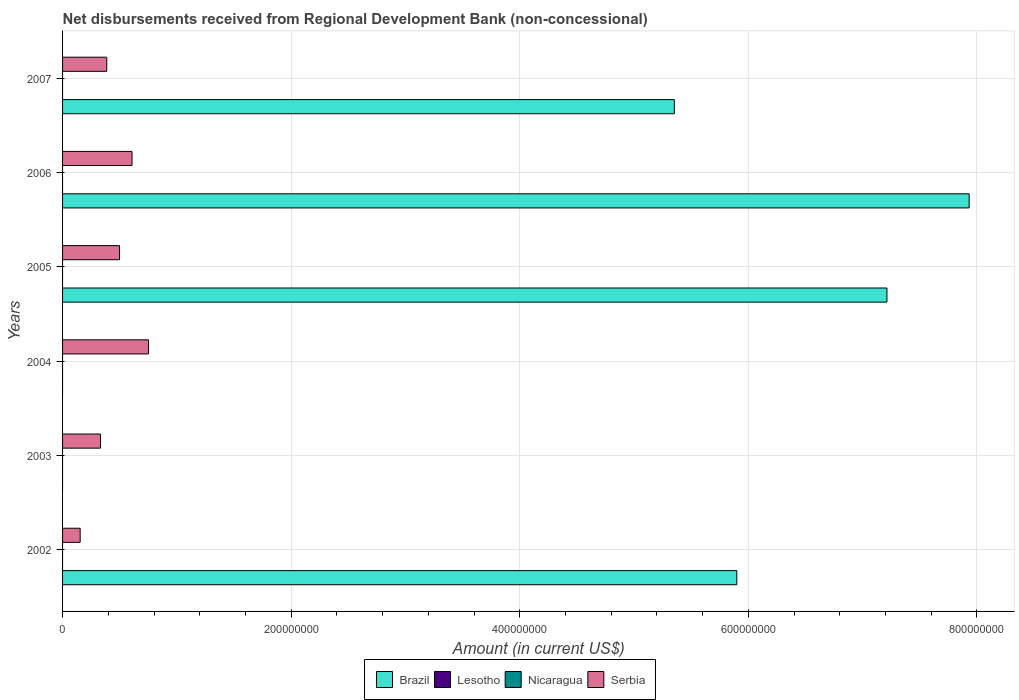Are the number of bars on each tick of the Y-axis equal?
Your answer should be very brief. No. How many bars are there on the 5th tick from the top?
Provide a short and direct response. 1. In how many cases, is the number of bars for a given year not equal to the number of legend labels?
Offer a very short reply. 6. What is the amount of disbursements received from Regional Development Bank in Nicaragua in 2004?
Make the answer very short. 0. Across all years, what is the maximum amount of disbursements received from Regional Development Bank in Serbia?
Provide a short and direct response. 7.52e+07. Across all years, what is the minimum amount of disbursements received from Regional Development Bank in Lesotho?
Your answer should be very brief. 0. In which year was the amount of disbursements received from Regional Development Bank in Serbia maximum?
Your response must be concise. 2004. What is the total amount of disbursements received from Regional Development Bank in Nicaragua in the graph?
Keep it short and to the point. 0. What is the difference between the amount of disbursements received from Regional Development Bank in Serbia in 2002 and that in 2005?
Provide a short and direct response. -3.44e+07. What is the ratio of the amount of disbursements received from Regional Development Bank in Serbia in 2005 to that in 2007?
Make the answer very short. 1.29. Is the amount of disbursements received from Regional Development Bank in Serbia in 2004 less than that in 2007?
Make the answer very short. No. What is the difference between the highest and the second highest amount of disbursements received from Regional Development Bank in Brazil?
Ensure brevity in your answer.  7.19e+07. What is the difference between the highest and the lowest amount of disbursements received from Regional Development Bank in Serbia?
Provide a succinct answer. 5.98e+07. Is the sum of the amount of disbursements received from Regional Development Bank in Brazil in 2002 and 2006 greater than the maximum amount of disbursements received from Regional Development Bank in Nicaragua across all years?
Ensure brevity in your answer.  Yes. Is it the case that in every year, the sum of the amount of disbursements received from Regional Development Bank in Lesotho and amount of disbursements received from Regional Development Bank in Serbia is greater than the sum of amount of disbursements received from Regional Development Bank in Nicaragua and amount of disbursements received from Regional Development Bank in Brazil?
Give a very brief answer. Yes. Is it the case that in every year, the sum of the amount of disbursements received from Regional Development Bank in Serbia and amount of disbursements received from Regional Development Bank in Brazil is greater than the amount of disbursements received from Regional Development Bank in Nicaragua?
Keep it short and to the point. Yes. Are the values on the major ticks of X-axis written in scientific E-notation?
Your response must be concise. No. How many legend labels are there?
Give a very brief answer. 4. What is the title of the graph?
Make the answer very short. Net disbursements received from Regional Development Bank (non-concessional). What is the label or title of the X-axis?
Your answer should be compact. Amount (in current US$). What is the label or title of the Y-axis?
Provide a succinct answer. Years. What is the Amount (in current US$) in Brazil in 2002?
Give a very brief answer. 5.90e+08. What is the Amount (in current US$) in Nicaragua in 2002?
Offer a very short reply. 0. What is the Amount (in current US$) in Serbia in 2002?
Make the answer very short. 1.54e+07. What is the Amount (in current US$) of Brazil in 2003?
Your response must be concise. 0. What is the Amount (in current US$) in Serbia in 2003?
Your answer should be very brief. 3.32e+07. What is the Amount (in current US$) in Brazil in 2004?
Offer a terse response. 0. What is the Amount (in current US$) of Lesotho in 2004?
Offer a very short reply. 0. What is the Amount (in current US$) in Nicaragua in 2004?
Your response must be concise. 0. What is the Amount (in current US$) in Serbia in 2004?
Offer a very short reply. 7.52e+07. What is the Amount (in current US$) in Brazil in 2005?
Your answer should be compact. 7.21e+08. What is the Amount (in current US$) in Nicaragua in 2005?
Keep it short and to the point. 0. What is the Amount (in current US$) of Serbia in 2005?
Your response must be concise. 4.98e+07. What is the Amount (in current US$) of Brazil in 2006?
Provide a succinct answer. 7.93e+08. What is the Amount (in current US$) in Serbia in 2006?
Your response must be concise. 6.08e+07. What is the Amount (in current US$) of Brazil in 2007?
Keep it short and to the point. 5.35e+08. What is the Amount (in current US$) in Lesotho in 2007?
Your response must be concise. 0. What is the Amount (in current US$) of Serbia in 2007?
Keep it short and to the point. 3.87e+07. Across all years, what is the maximum Amount (in current US$) in Brazil?
Your answer should be very brief. 7.93e+08. Across all years, what is the maximum Amount (in current US$) in Serbia?
Offer a very short reply. 7.52e+07. Across all years, what is the minimum Amount (in current US$) in Brazil?
Give a very brief answer. 0. Across all years, what is the minimum Amount (in current US$) of Serbia?
Offer a very short reply. 1.54e+07. What is the total Amount (in current US$) in Brazil in the graph?
Your response must be concise. 2.64e+09. What is the total Amount (in current US$) of Lesotho in the graph?
Your answer should be compact. 0. What is the total Amount (in current US$) in Serbia in the graph?
Give a very brief answer. 2.73e+08. What is the difference between the Amount (in current US$) of Serbia in 2002 and that in 2003?
Offer a very short reply. -1.78e+07. What is the difference between the Amount (in current US$) of Serbia in 2002 and that in 2004?
Keep it short and to the point. -5.98e+07. What is the difference between the Amount (in current US$) of Brazil in 2002 and that in 2005?
Offer a terse response. -1.31e+08. What is the difference between the Amount (in current US$) in Serbia in 2002 and that in 2005?
Your answer should be compact. -3.44e+07. What is the difference between the Amount (in current US$) of Brazil in 2002 and that in 2006?
Offer a terse response. -2.03e+08. What is the difference between the Amount (in current US$) of Serbia in 2002 and that in 2006?
Offer a terse response. -4.54e+07. What is the difference between the Amount (in current US$) in Brazil in 2002 and that in 2007?
Make the answer very short. 5.46e+07. What is the difference between the Amount (in current US$) of Serbia in 2002 and that in 2007?
Your answer should be very brief. -2.33e+07. What is the difference between the Amount (in current US$) in Serbia in 2003 and that in 2004?
Make the answer very short. -4.20e+07. What is the difference between the Amount (in current US$) of Serbia in 2003 and that in 2005?
Your answer should be very brief. -1.67e+07. What is the difference between the Amount (in current US$) in Serbia in 2003 and that in 2006?
Your response must be concise. -2.76e+07. What is the difference between the Amount (in current US$) in Serbia in 2003 and that in 2007?
Provide a short and direct response. -5.47e+06. What is the difference between the Amount (in current US$) in Serbia in 2004 and that in 2005?
Keep it short and to the point. 2.54e+07. What is the difference between the Amount (in current US$) of Serbia in 2004 and that in 2006?
Make the answer very short. 1.45e+07. What is the difference between the Amount (in current US$) in Serbia in 2004 and that in 2007?
Provide a succinct answer. 3.66e+07. What is the difference between the Amount (in current US$) in Brazil in 2005 and that in 2006?
Your response must be concise. -7.19e+07. What is the difference between the Amount (in current US$) in Serbia in 2005 and that in 2006?
Your answer should be very brief. -1.09e+07. What is the difference between the Amount (in current US$) of Brazil in 2005 and that in 2007?
Your answer should be very brief. 1.86e+08. What is the difference between the Amount (in current US$) of Serbia in 2005 and that in 2007?
Provide a short and direct response. 1.12e+07. What is the difference between the Amount (in current US$) of Brazil in 2006 and that in 2007?
Give a very brief answer. 2.58e+08. What is the difference between the Amount (in current US$) of Serbia in 2006 and that in 2007?
Offer a very short reply. 2.21e+07. What is the difference between the Amount (in current US$) in Brazil in 2002 and the Amount (in current US$) in Serbia in 2003?
Ensure brevity in your answer.  5.57e+08. What is the difference between the Amount (in current US$) in Brazil in 2002 and the Amount (in current US$) in Serbia in 2004?
Offer a very short reply. 5.15e+08. What is the difference between the Amount (in current US$) of Brazil in 2002 and the Amount (in current US$) of Serbia in 2005?
Provide a succinct answer. 5.40e+08. What is the difference between the Amount (in current US$) of Brazil in 2002 and the Amount (in current US$) of Serbia in 2006?
Offer a terse response. 5.29e+08. What is the difference between the Amount (in current US$) in Brazil in 2002 and the Amount (in current US$) in Serbia in 2007?
Give a very brief answer. 5.51e+08. What is the difference between the Amount (in current US$) in Brazil in 2005 and the Amount (in current US$) in Serbia in 2006?
Offer a very short reply. 6.61e+08. What is the difference between the Amount (in current US$) in Brazil in 2005 and the Amount (in current US$) in Serbia in 2007?
Give a very brief answer. 6.83e+08. What is the difference between the Amount (in current US$) in Brazil in 2006 and the Amount (in current US$) in Serbia in 2007?
Keep it short and to the point. 7.55e+08. What is the average Amount (in current US$) in Brazil per year?
Offer a very short reply. 4.40e+08. What is the average Amount (in current US$) in Lesotho per year?
Give a very brief answer. 0. What is the average Amount (in current US$) of Nicaragua per year?
Provide a short and direct response. 0. What is the average Amount (in current US$) in Serbia per year?
Keep it short and to the point. 4.55e+07. In the year 2002, what is the difference between the Amount (in current US$) of Brazil and Amount (in current US$) of Serbia?
Your response must be concise. 5.75e+08. In the year 2005, what is the difference between the Amount (in current US$) of Brazil and Amount (in current US$) of Serbia?
Offer a very short reply. 6.71e+08. In the year 2006, what is the difference between the Amount (in current US$) in Brazil and Amount (in current US$) in Serbia?
Provide a succinct answer. 7.32e+08. In the year 2007, what is the difference between the Amount (in current US$) in Brazil and Amount (in current US$) in Serbia?
Make the answer very short. 4.97e+08. What is the ratio of the Amount (in current US$) of Serbia in 2002 to that in 2003?
Offer a terse response. 0.46. What is the ratio of the Amount (in current US$) in Serbia in 2002 to that in 2004?
Ensure brevity in your answer.  0.2. What is the ratio of the Amount (in current US$) in Brazil in 2002 to that in 2005?
Keep it short and to the point. 0.82. What is the ratio of the Amount (in current US$) of Serbia in 2002 to that in 2005?
Make the answer very short. 0.31. What is the ratio of the Amount (in current US$) of Brazil in 2002 to that in 2006?
Offer a terse response. 0.74. What is the ratio of the Amount (in current US$) in Serbia in 2002 to that in 2006?
Provide a short and direct response. 0.25. What is the ratio of the Amount (in current US$) of Brazil in 2002 to that in 2007?
Offer a very short reply. 1.1. What is the ratio of the Amount (in current US$) of Serbia in 2002 to that in 2007?
Your response must be concise. 0.4. What is the ratio of the Amount (in current US$) in Serbia in 2003 to that in 2004?
Make the answer very short. 0.44. What is the ratio of the Amount (in current US$) of Serbia in 2003 to that in 2005?
Offer a terse response. 0.67. What is the ratio of the Amount (in current US$) of Serbia in 2003 to that in 2006?
Ensure brevity in your answer.  0.55. What is the ratio of the Amount (in current US$) of Serbia in 2003 to that in 2007?
Make the answer very short. 0.86. What is the ratio of the Amount (in current US$) in Serbia in 2004 to that in 2005?
Provide a short and direct response. 1.51. What is the ratio of the Amount (in current US$) of Serbia in 2004 to that in 2006?
Keep it short and to the point. 1.24. What is the ratio of the Amount (in current US$) of Serbia in 2004 to that in 2007?
Make the answer very short. 1.95. What is the ratio of the Amount (in current US$) in Brazil in 2005 to that in 2006?
Make the answer very short. 0.91. What is the ratio of the Amount (in current US$) of Serbia in 2005 to that in 2006?
Provide a succinct answer. 0.82. What is the ratio of the Amount (in current US$) in Brazil in 2005 to that in 2007?
Offer a very short reply. 1.35. What is the ratio of the Amount (in current US$) in Serbia in 2005 to that in 2007?
Make the answer very short. 1.29. What is the ratio of the Amount (in current US$) in Brazil in 2006 to that in 2007?
Your answer should be very brief. 1.48. What is the ratio of the Amount (in current US$) of Serbia in 2006 to that in 2007?
Provide a succinct answer. 1.57. What is the difference between the highest and the second highest Amount (in current US$) in Brazil?
Provide a succinct answer. 7.19e+07. What is the difference between the highest and the second highest Amount (in current US$) in Serbia?
Keep it short and to the point. 1.45e+07. What is the difference between the highest and the lowest Amount (in current US$) of Brazil?
Keep it short and to the point. 7.93e+08. What is the difference between the highest and the lowest Amount (in current US$) of Serbia?
Keep it short and to the point. 5.98e+07. 